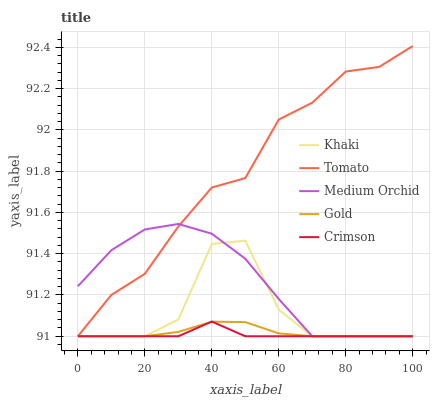Does Medium Orchid have the minimum area under the curve?
Answer yes or no. No. Does Medium Orchid have the maximum area under the curve?
Answer yes or no. No. Is Crimson the smoothest?
Answer yes or no. No. Is Crimson the roughest?
Answer yes or no. No. Does Crimson have the highest value?
Answer yes or no. No. 